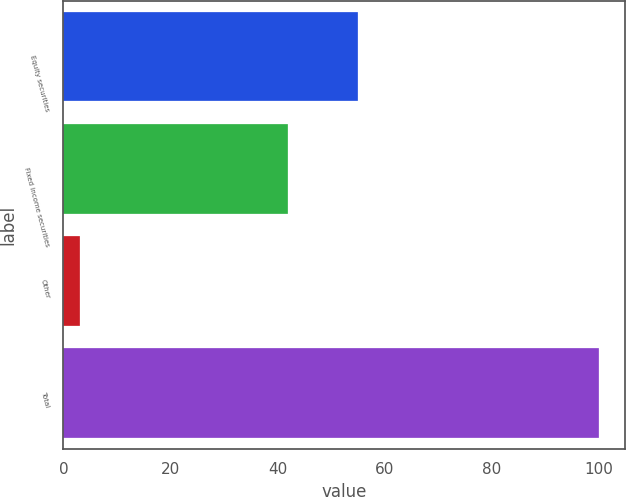Convert chart. <chart><loc_0><loc_0><loc_500><loc_500><bar_chart><fcel>Equity securities<fcel>Fixed income securities<fcel>Other<fcel>Total<nl><fcel>55<fcel>42<fcel>3<fcel>100<nl></chart> 